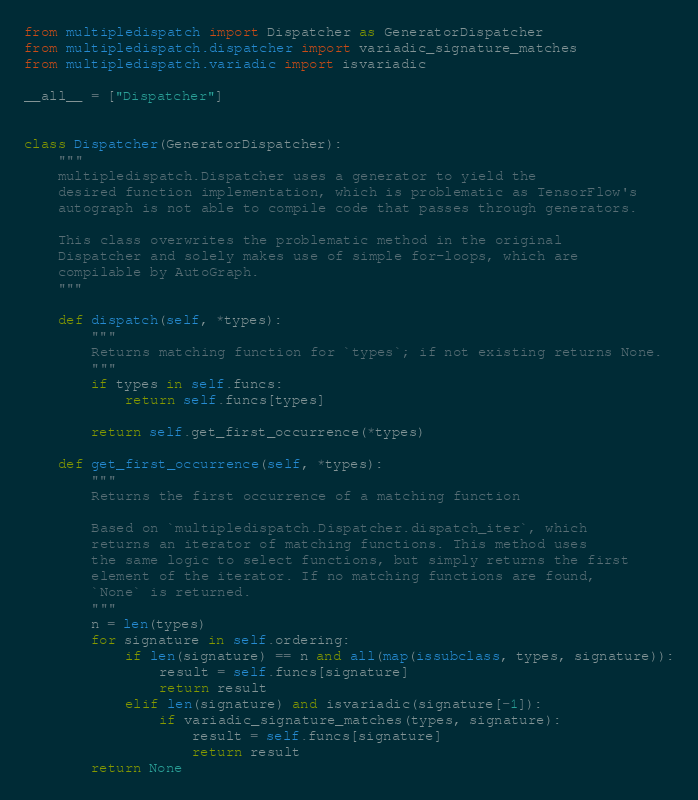Convert code to text. <code><loc_0><loc_0><loc_500><loc_500><_Python_>from multipledispatch import Dispatcher as GeneratorDispatcher
from multipledispatch.dispatcher import variadic_signature_matches
from multipledispatch.variadic import isvariadic

__all__ = ["Dispatcher"]


class Dispatcher(GeneratorDispatcher):
    """
    multipledispatch.Dispatcher uses a generator to yield the 
    desired function implementation, which is problematic as TensorFlow's
    autograph is not able to compile code that passes through generators.

    This class overwrites the problematic method in the original
    Dispatcher and solely makes use of simple for-loops, which are
    compilable by AutoGraph.
    """

    def dispatch(self, *types):
        """
        Returns matching function for `types`; if not existing returns None.
        """
        if types in self.funcs:
            return self.funcs[types]

        return self.get_first_occurrence(*types)

    def get_first_occurrence(self, *types):
        """ 
        Returns the first occurrence of a matching function 
        
        Based on `multipledispatch.Dispatcher.dispatch_iter`, which
        returns an iterator of matching functions. This method uses
        the same logic to select functions, but simply returns the first
        element of the iterator. If no matching functions are found, 
        `None` is returned.
        """
        n = len(types)
        for signature in self.ordering:
            if len(signature) == n and all(map(issubclass, types, signature)):
                result = self.funcs[signature]
                return result
            elif len(signature) and isvariadic(signature[-1]):
                if variadic_signature_matches(types, signature):
                    result = self.funcs[signature]
                    return result
        return None
</code> 